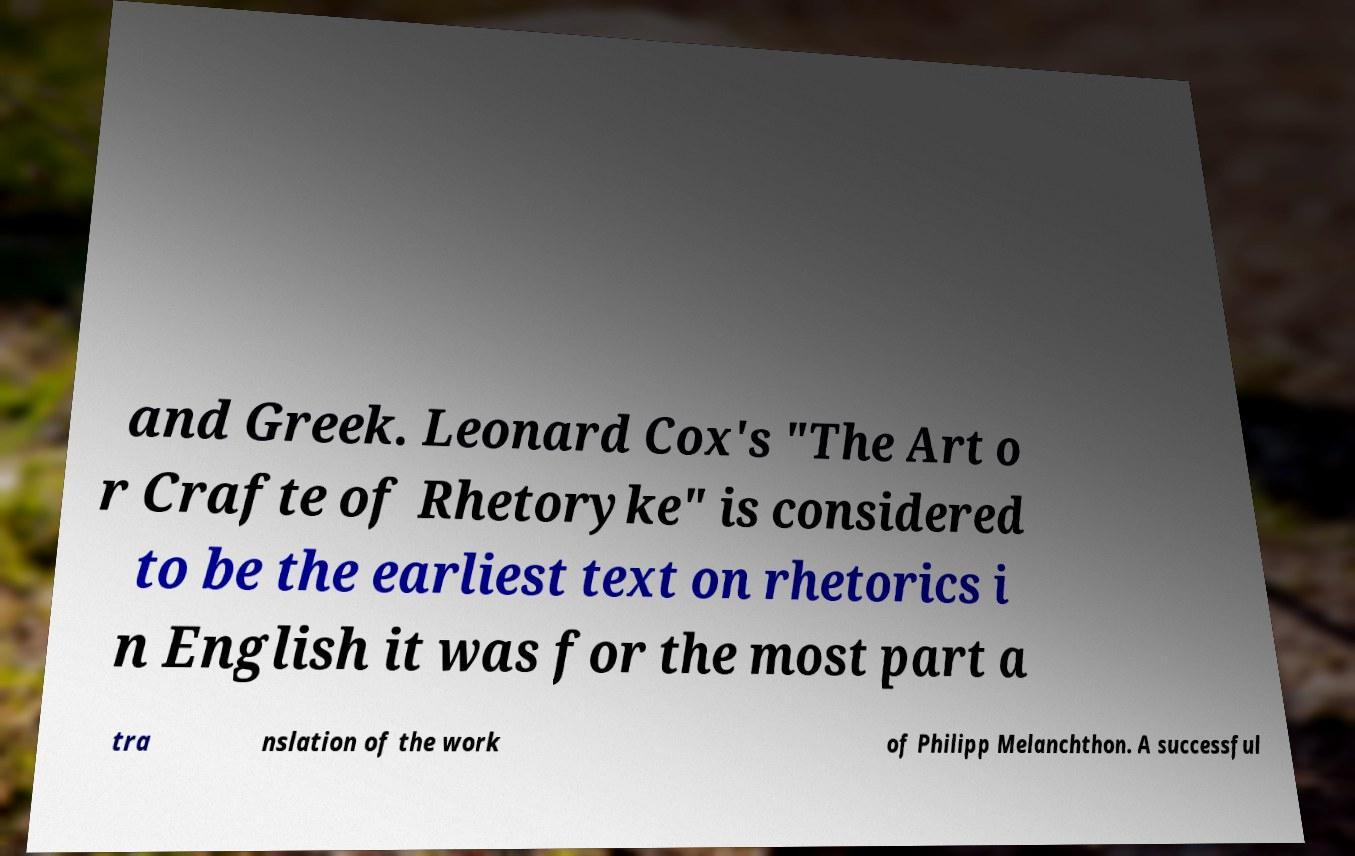Please identify and transcribe the text found in this image. and Greek. Leonard Cox's "The Art o r Crafte of Rhetoryke" is considered to be the earliest text on rhetorics i n English it was for the most part a tra nslation of the work of Philipp Melanchthon. A successful 